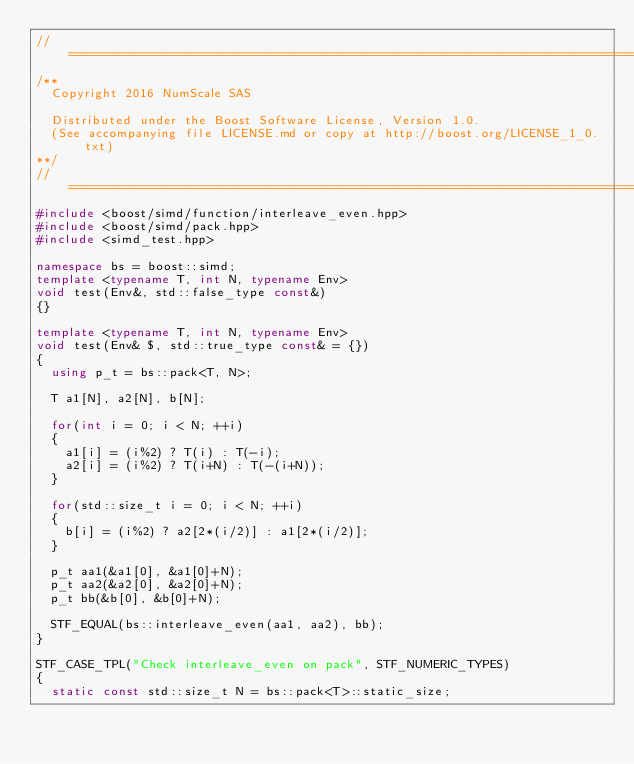<code> <loc_0><loc_0><loc_500><loc_500><_C++_>//==================================================================================================
/**
  Copyright 2016 NumScale SAS

  Distributed under the Boost Software License, Version 1.0.
  (See accompanying file LICENSE.md or copy at http://boost.org/LICENSE_1_0.txt)
**/
//==================================================================================================
#include <boost/simd/function/interleave_even.hpp>
#include <boost/simd/pack.hpp>
#include <simd_test.hpp>

namespace bs = boost::simd;
template <typename T, int N, typename Env>
void test(Env&, std::false_type const&)
{}

template <typename T, int N, typename Env>
void test(Env& $, std::true_type const& = {})
{
  using p_t = bs::pack<T, N>;

  T a1[N], a2[N], b[N];

  for(int i = 0; i < N; ++i)
  {
    a1[i] = (i%2) ? T(i) : T(-i);
    a2[i] = (i%2) ? T(i+N) : T(-(i+N));
  }

  for(std::size_t i = 0; i < N; ++i)
  {
    b[i] = (i%2) ? a2[2*(i/2)] : a1[2*(i/2)];
  }

  p_t aa1(&a1[0], &a1[0]+N);
  p_t aa2(&a2[0], &a2[0]+N);
  p_t bb(&b[0], &b[0]+N);

  STF_EQUAL(bs::interleave_even(aa1, aa2), bb);
}

STF_CASE_TPL("Check interleave_even on pack", STF_NUMERIC_TYPES)
{
  static const std::size_t N = bs::pack<T>::static_size;
</code> 